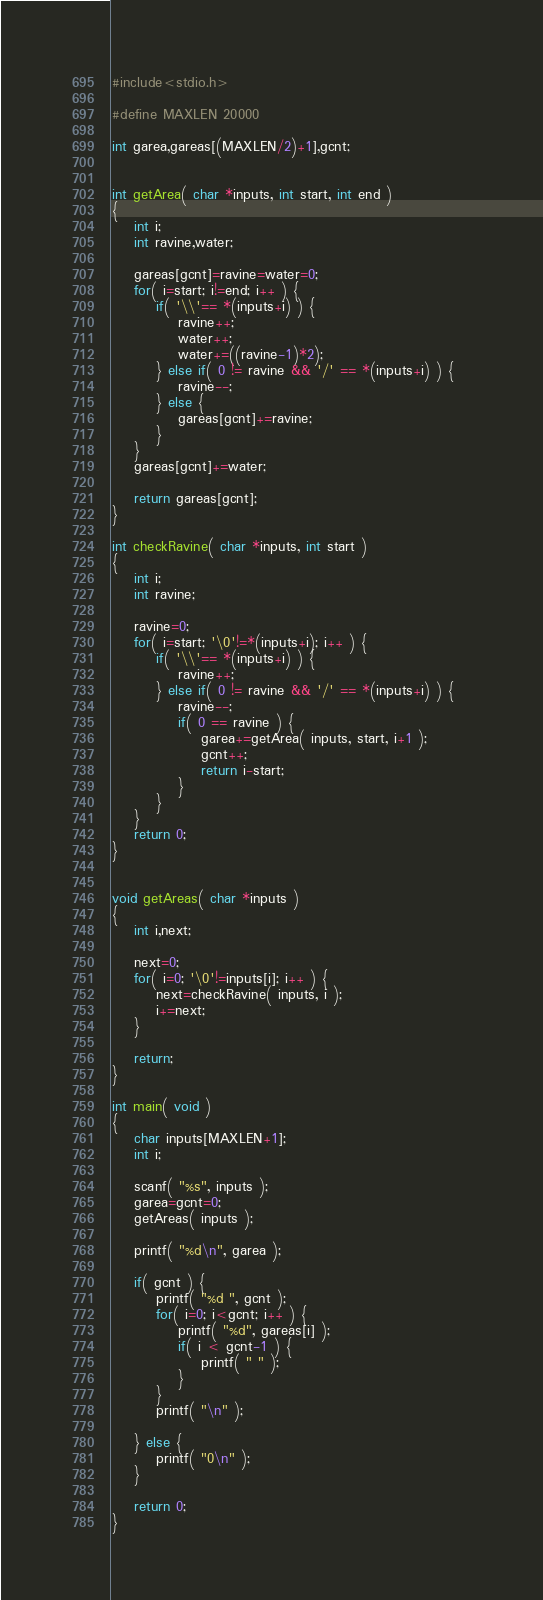Convert code to text. <code><loc_0><loc_0><loc_500><loc_500><_C_>#include<stdio.h>
 
#define MAXLEN 20000
 
int garea,gareas[(MAXLEN/2)+1],gcnt;
 
 
int getArea( char *inputs, int start, int end )
{
    int i;
    int ravine,water;
    
    gareas[gcnt]=ravine=water=0;
    for( i=start; i!=end; i++ ) {
        if( '\\'== *(inputs+i) ) {
            ravine++;
            water++;
           	water+=((ravine-1)*2);
        } else if( 0 != ravine && '/' == *(inputs+i) ) {
        	ravine--;
        } else {
	     	gareas[gcnt]+=ravine;
        }       
    }
	gareas[gcnt]+=water;
    
    return gareas[gcnt];
}
  
int checkRavine( char *inputs, int start )
{
    int i;
    int ravine;
    
    ravine=0;
    for( i=start; '\0'!=*(inputs+i); i++ ) {
        if( '\\'== *(inputs+i) ) {
            ravine++;
        } else if( 0 != ravine && '/' == *(inputs+i) ) {   
            ravine--;
            if( 0 == ravine ) {
            	garea+=getArea( inputs, start, i+1 );
            	gcnt++;
                return i-start;
            }           
        }
    }
    return 0;
}
 
 
void getAreas( char *inputs )
{
    int i,next;
     
    next=0;
    for( i=0; '\0'!=inputs[i]; i++ ) {
        next=checkRavine( inputs, i );
        i+=next;
    }
 
    return;
}
 
int main( void ) 
{
    char inputs[MAXLEN+1];
    int i;
 
    scanf( "%s", inputs );
    garea=gcnt=0;
    getAreas( inputs );
     
    printf( "%d\n", garea );
    
    if( gcnt ) {
        printf( "%d ", gcnt );
        for( i=0; i<gcnt; i++ ) {
            printf( "%d", gareas[i] );
            if( i < gcnt-1 ) {
            	printf( " " );  
            }
        }
        printf( "\n" );
       
    } else {
        printf( "0\n" );
    }
     
    return 0;
}</code> 